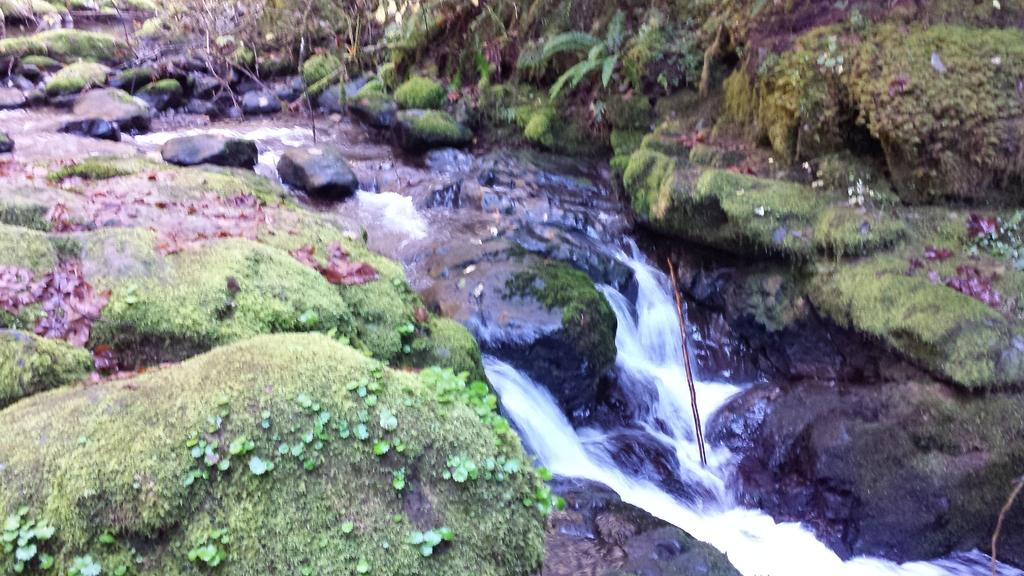What is the primary element visible in the image? There is water in the image. What type of natural features can be seen in the image? There are rocks and plants in the image. Are there any other objects present besides the rocks and plants? Yes, there are other unspecified objects in the image. How does the sense of shame manifest itself in the image? There is no indication of shame or any emotional state in the image, as it primarily features natural elements such as water, rocks, and plants. 